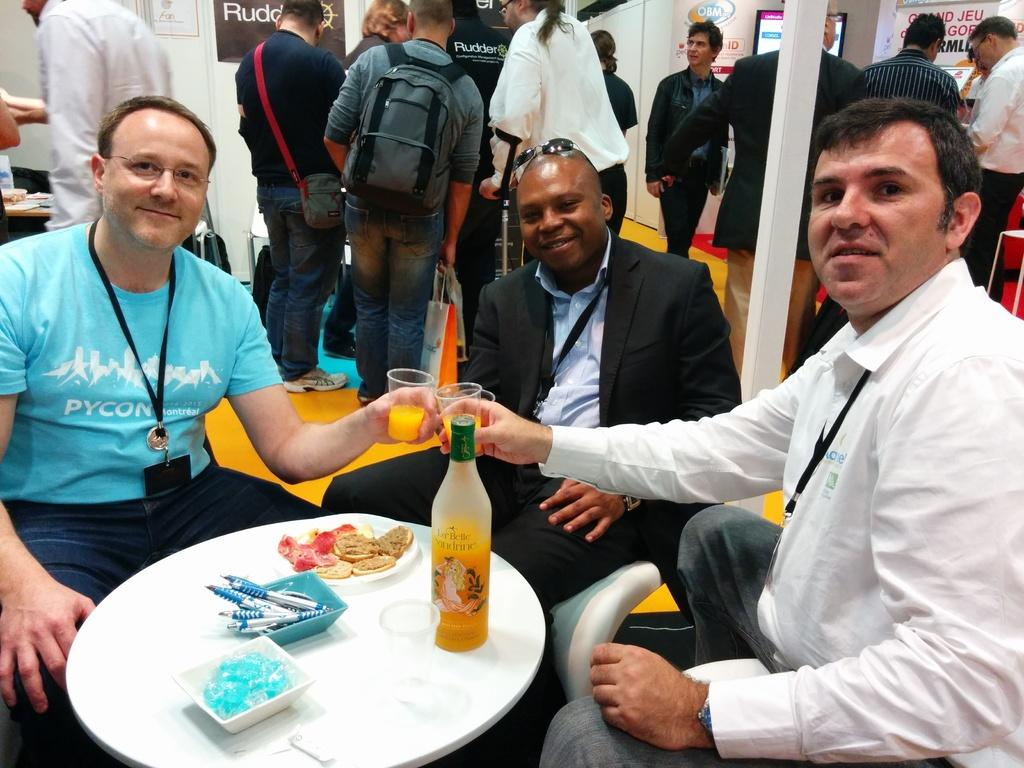How many men are in the image? There are three men in the image. What are the men doing in the image? The men are sitting around a table. What items can be seen on the table can be seen in the image? Soft drink bottles, drink bottles, chips, pens, and glasses are on the table. Can you describe the people in the background of the image? There are people standing in the background of the image. What type of vest is the man wearing in the image? There is no vest visible on any of the men in the image. How many quarters are on the table in the image? There are no quarters present on the table in the image. 